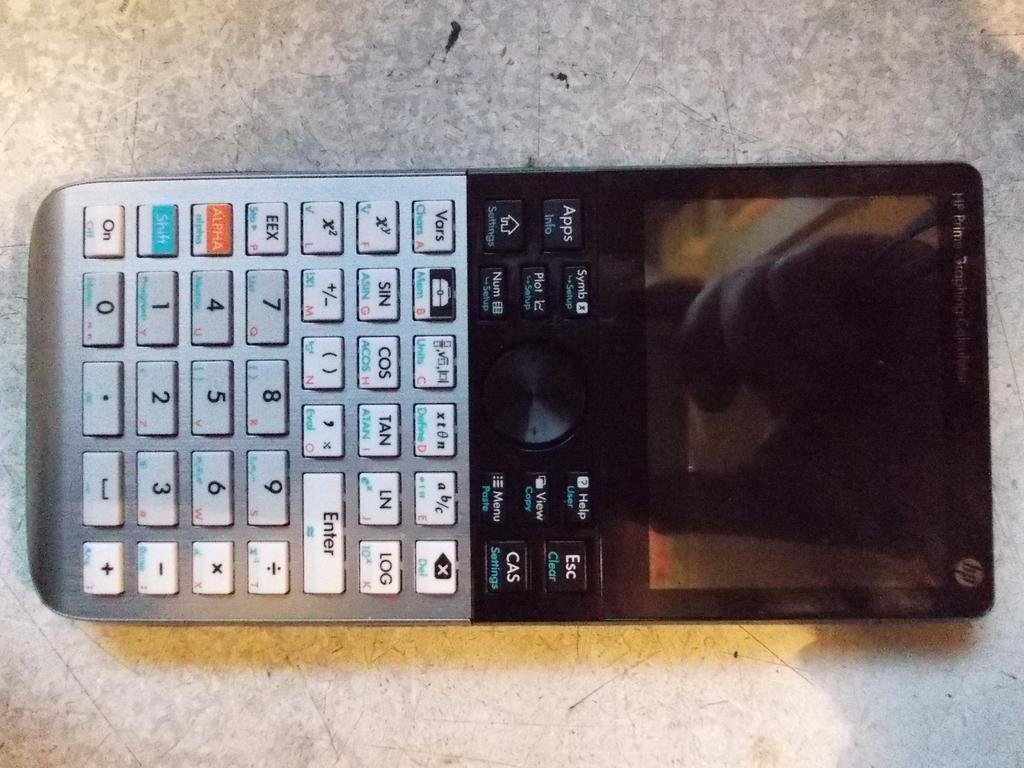What kind of button is at the top right of the calculator?
Ensure brevity in your answer.  Esc. What does the orange button say?
Offer a very short reply. Alpha. 